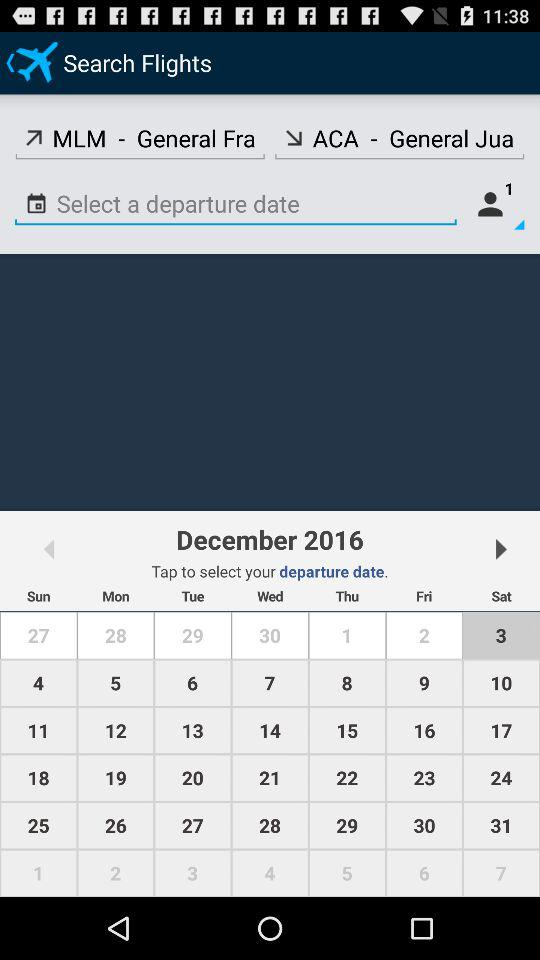How many passengers are there? There is 1 passenger. 